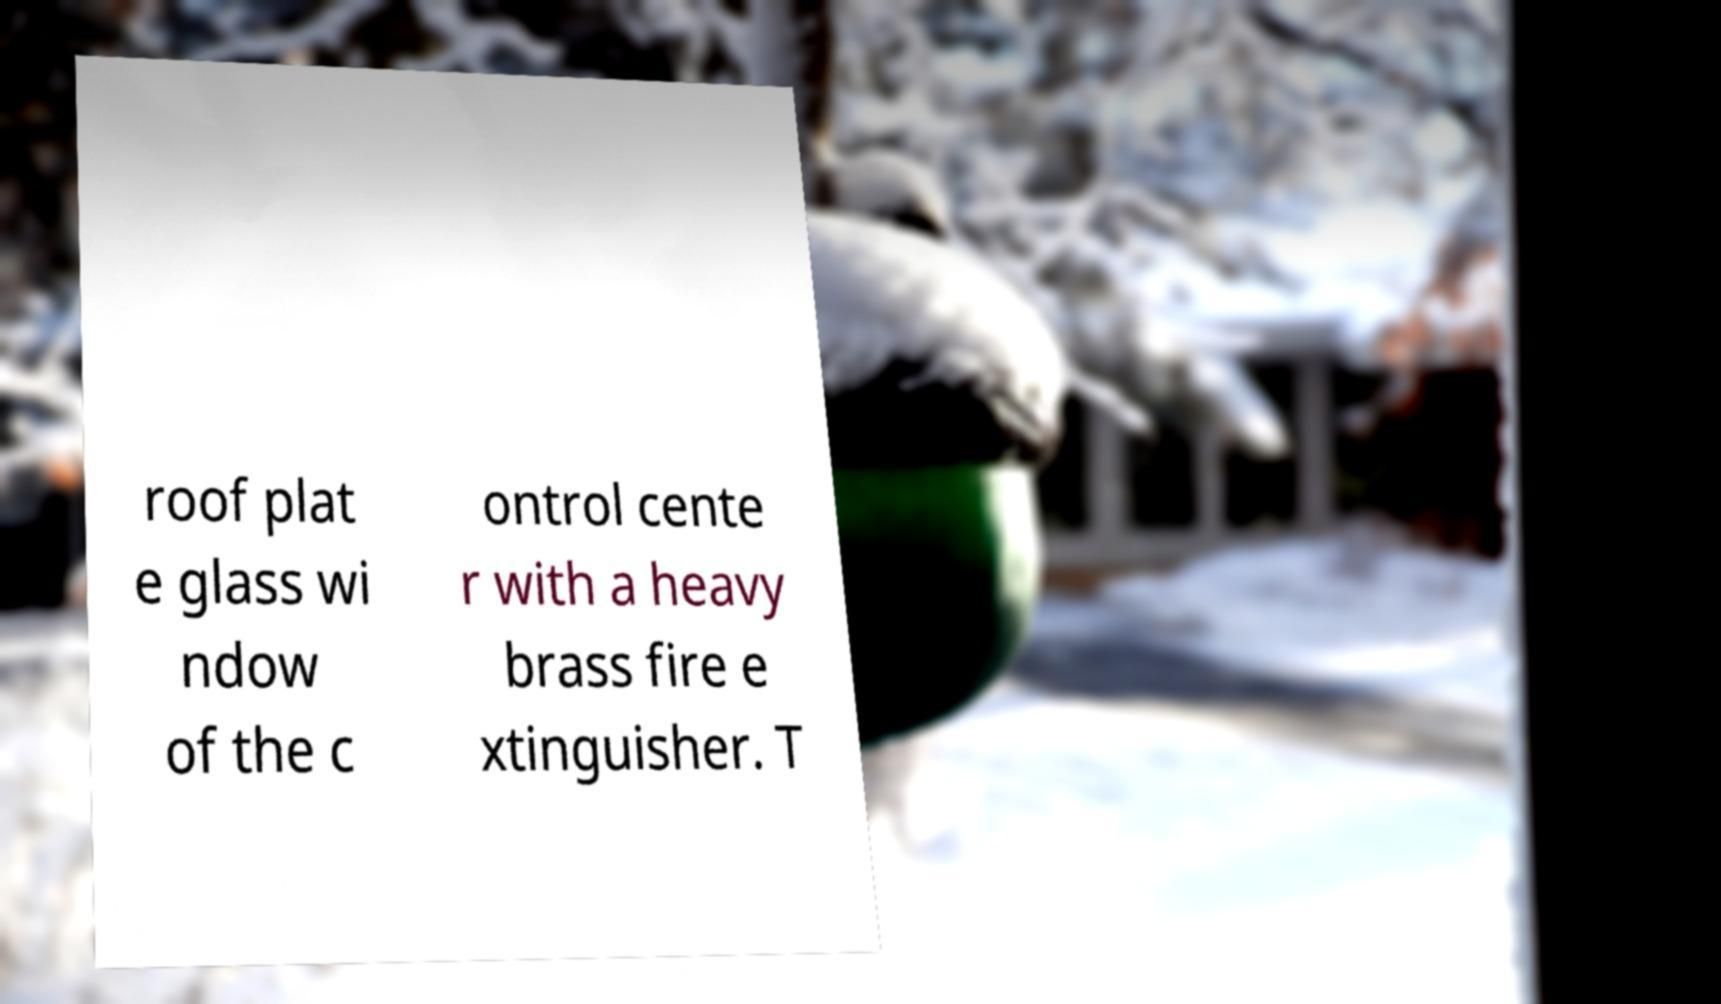For documentation purposes, I need the text within this image transcribed. Could you provide that? roof plat e glass wi ndow of the c ontrol cente r with a heavy brass fire e xtinguisher. T 